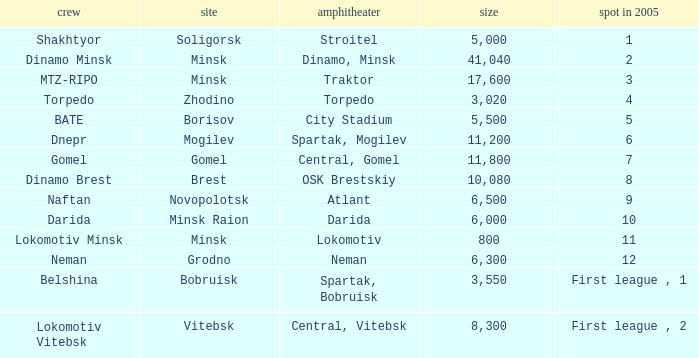Can you tell me the Capacity that has the Position in 2005 of 8? 10080.0. 